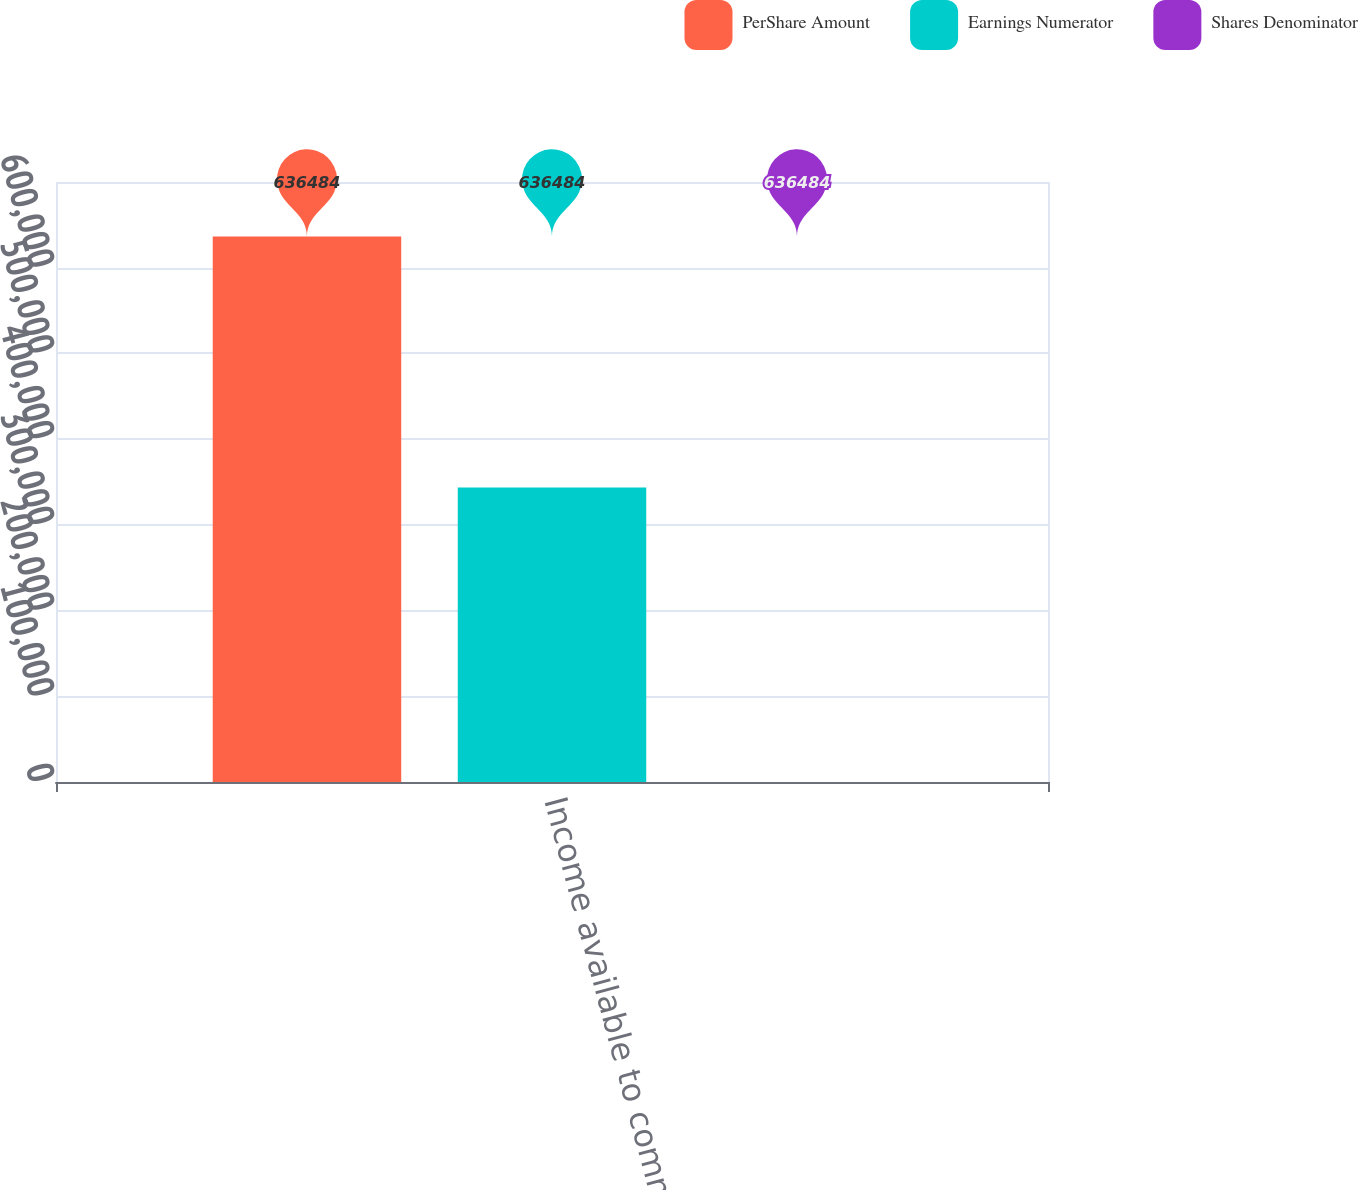Convert chart. <chart><loc_0><loc_0><loc_500><loc_500><stacked_bar_chart><ecel><fcel>Income available to common<nl><fcel>PerShare Amount<fcel>636484<nl><fcel>Earnings Numerator<fcel>343653<nl><fcel>Shares Denominator<fcel>1.85<nl></chart> 